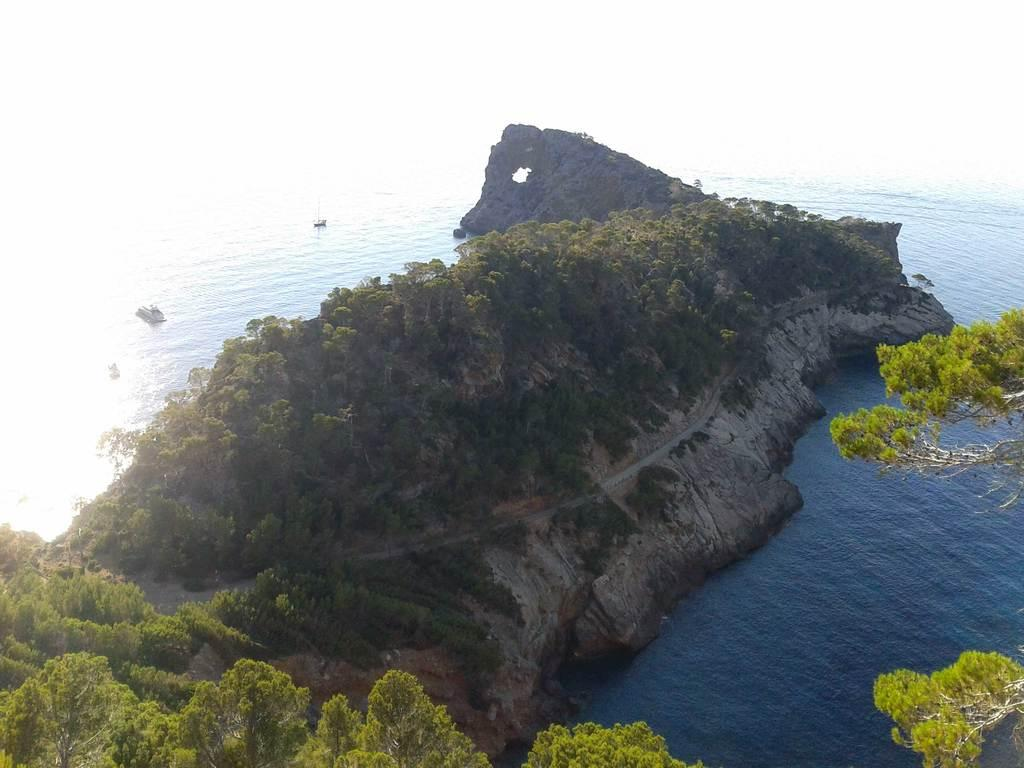What type of vegetation can be seen in the image? There are trees in the image. What natural element is visible besides the trees? There is water visible in the image. What can be seen in the background of the image? The sky is visible in the background of the image. What type of coal is being selected by the trees in the image? There is no coal present in the image, and the trees are not selecting anything. 